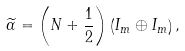<formula> <loc_0><loc_0><loc_500><loc_500>\widetilde { \alpha } = \left ( N + \frac { 1 } { 2 } \right ) \left ( I _ { m } \oplus I _ { m } \right ) ,</formula> 